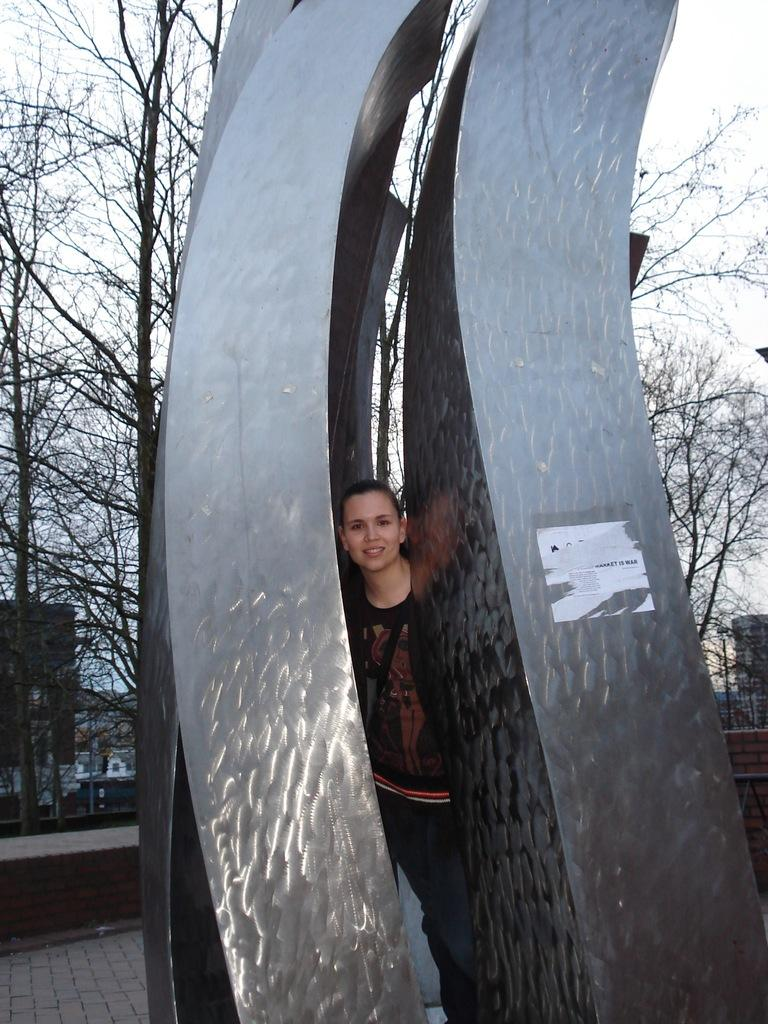How many pillars are present in the image? There are four pillars in the image. What is the woman in the image doing? The woman is standing between the pillars. What can be seen in the background of the image? There is a tree and the sky visible in the background of the image. What type of shop is located near the pillars in the image? There is no shop present in the image; it only features four pillars and a woman standing between them. What government policy is being discussed by the woman standing between the pillars? There is no indication of any discussion or policy in the image; it only shows a woman standing between pillars with a tree and the sky in the background. 